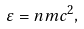Convert formula to latex. <formula><loc_0><loc_0><loc_500><loc_500>\varepsilon = n m c ^ { 2 } ,</formula> 